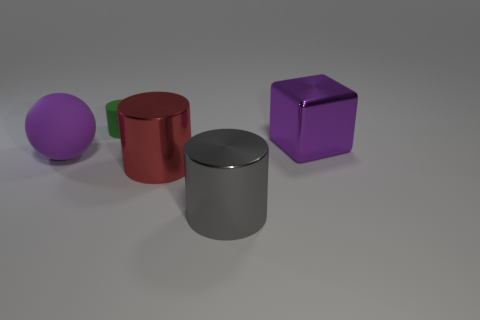What number of other objects are there of the same size as the purple metal thing?
Keep it short and to the point. 3. What is the material of the large red cylinder in front of the purple object to the right of the small cylinder?
Give a very brief answer. Metal. Are there any big things in front of the metallic block?
Your response must be concise. Yes. Are there more small cylinders that are behind the purple matte ball than small cyan spheres?
Your answer should be very brief. Yes. Is there a shiny block that has the same color as the ball?
Provide a short and direct response. Yes. The shiny cube that is the same size as the ball is what color?
Keep it short and to the point. Purple. Is there a big purple thing that is behind the thing that is on the left side of the matte cylinder?
Make the answer very short. Yes. There is a purple object to the right of the small green matte thing; what is it made of?
Give a very brief answer. Metal. Is the large purple object that is to the left of the gray metallic object made of the same material as the cylinder behind the sphere?
Provide a succinct answer. Yes. Are there the same number of large red cylinders to the right of the large red shiny thing and large purple objects left of the purple shiny thing?
Make the answer very short. No. 